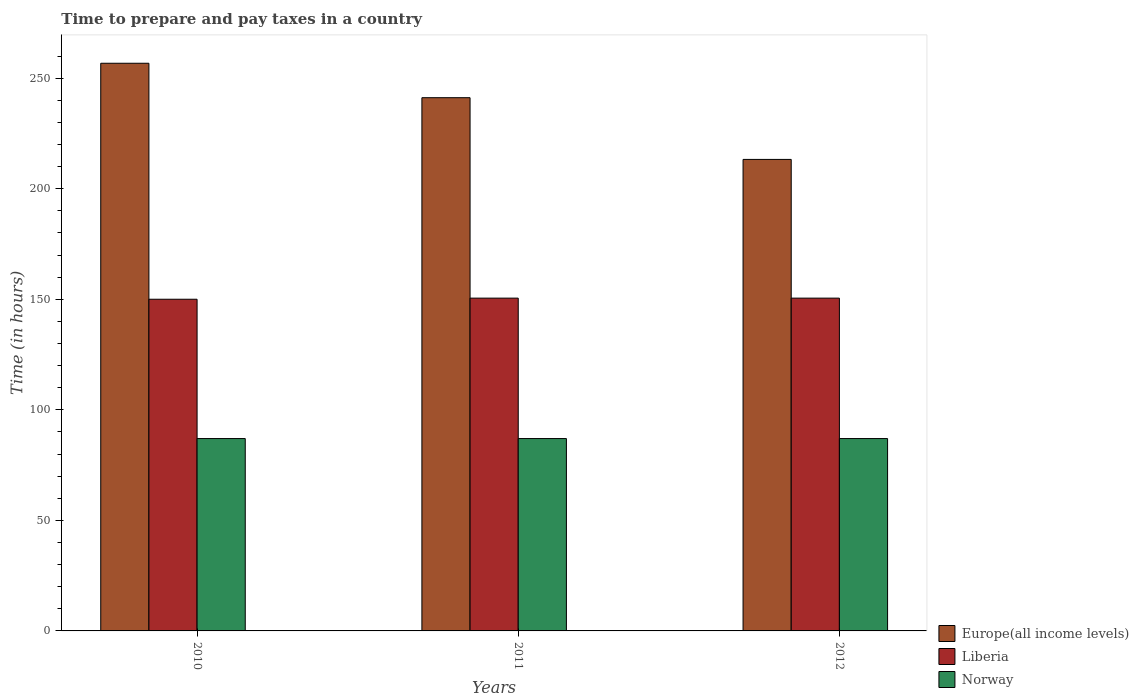How many different coloured bars are there?
Offer a terse response. 3. How many bars are there on the 3rd tick from the left?
Ensure brevity in your answer.  3. How many bars are there on the 2nd tick from the right?
Provide a succinct answer. 3. What is the number of hours required to prepare and pay taxes in Europe(all income levels) in 2012?
Offer a terse response. 213.24. Across all years, what is the maximum number of hours required to prepare and pay taxes in Norway?
Make the answer very short. 87. Across all years, what is the minimum number of hours required to prepare and pay taxes in Europe(all income levels)?
Your answer should be compact. 213.24. In which year was the number of hours required to prepare and pay taxes in Liberia minimum?
Your response must be concise. 2010. What is the total number of hours required to prepare and pay taxes in Norway in the graph?
Keep it short and to the point. 261. What is the difference between the number of hours required to prepare and pay taxes in Liberia in 2010 and that in 2012?
Your answer should be compact. -0.5. What is the difference between the number of hours required to prepare and pay taxes in Liberia in 2010 and the number of hours required to prepare and pay taxes in Norway in 2012?
Your answer should be very brief. 63. What is the average number of hours required to prepare and pay taxes in Europe(all income levels) per year?
Provide a succinct answer. 237.04. In the year 2011, what is the difference between the number of hours required to prepare and pay taxes in Norway and number of hours required to prepare and pay taxes in Liberia?
Provide a short and direct response. -63.5. What is the difference between the highest and the lowest number of hours required to prepare and pay taxes in Liberia?
Give a very brief answer. 0.5. In how many years, is the number of hours required to prepare and pay taxes in Liberia greater than the average number of hours required to prepare and pay taxes in Liberia taken over all years?
Ensure brevity in your answer.  2. What does the 2nd bar from the left in 2012 represents?
Keep it short and to the point. Liberia. What does the 2nd bar from the right in 2010 represents?
Your answer should be very brief. Liberia. Is it the case that in every year, the sum of the number of hours required to prepare and pay taxes in Norway and number of hours required to prepare and pay taxes in Liberia is greater than the number of hours required to prepare and pay taxes in Europe(all income levels)?
Your response must be concise. No. How many bars are there?
Provide a short and direct response. 9. What is the difference between two consecutive major ticks on the Y-axis?
Make the answer very short. 50. Are the values on the major ticks of Y-axis written in scientific E-notation?
Your answer should be very brief. No. Does the graph contain grids?
Your answer should be compact. No. How many legend labels are there?
Your response must be concise. 3. What is the title of the graph?
Provide a succinct answer. Time to prepare and pay taxes in a country. What is the label or title of the X-axis?
Provide a succinct answer. Years. What is the label or title of the Y-axis?
Offer a very short reply. Time (in hours). What is the Time (in hours) in Europe(all income levels) in 2010?
Ensure brevity in your answer.  256.72. What is the Time (in hours) in Liberia in 2010?
Ensure brevity in your answer.  150. What is the Time (in hours) of Europe(all income levels) in 2011?
Keep it short and to the point. 241.15. What is the Time (in hours) in Liberia in 2011?
Your answer should be very brief. 150.5. What is the Time (in hours) in Europe(all income levels) in 2012?
Make the answer very short. 213.24. What is the Time (in hours) of Liberia in 2012?
Give a very brief answer. 150.5. What is the Time (in hours) of Norway in 2012?
Offer a very short reply. 87. Across all years, what is the maximum Time (in hours) in Europe(all income levels)?
Keep it short and to the point. 256.72. Across all years, what is the maximum Time (in hours) in Liberia?
Ensure brevity in your answer.  150.5. Across all years, what is the minimum Time (in hours) of Europe(all income levels)?
Provide a succinct answer. 213.24. Across all years, what is the minimum Time (in hours) of Liberia?
Keep it short and to the point. 150. Across all years, what is the minimum Time (in hours) in Norway?
Give a very brief answer. 87. What is the total Time (in hours) in Europe(all income levels) in the graph?
Provide a short and direct response. 711.11. What is the total Time (in hours) of Liberia in the graph?
Your answer should be very brief. 451. What is the total Time (in hours) of Norway in the graph?
Your response must be concise. 261. What is the difference between the Time (in hours) of Europe(all income levels) in 2010 and that in 2011?
Your answer should be very brief. 15.57. What is the difference between the Time (in hours) of Norway in 2010 and that in 2011?
Give a very brief answer. 0. What is the difference between the Time (in hours) in Europe(all income levels) in 2010 and that in 2012?
Keep it short and to the point. 43.48. What is the difference between the Time (in hours) in Norway in 2010 and that in 2012?
Offer a terse response. 0. What is the difference between the Time (in hours) of Europe(all income levels) in 2011 and that in 2012?
Offer a very short reply. 27.91. What is the difference between the Time (in hours) in Norway in 2011 and that in 2012?
Give a very brief answer. 0. What is the difference between the Time (in hours) of Europe(all income levels) in 2010 and the Time (in hours) of Liberia in 2011?
Provide a short and direct response. 106.22. What is the difference between the Time (in hours) of Europe(all income levels) in 2010 and the Time (in hours) of Norway in 2011?
Offer a terse response. 169.72. What is the difference between the Time (in hours) in Liberia in 2010 and the Time (in hours) in Norway in 2011?
Keep it short and to the point. 63. What is the difference between the Time (in hours) of Europe(all income levels) in 2010 and the Time (in hours) of Liberia in 2012?
Provide a succinct answer. 106.22. What is the difference between the Time (in hours) in Europe(all income levels) in 2010 and the Time (in hours) in Norway in 2012?
Your answer should be very brief. 169.72. What is the difference between the Time (in hours) of Europe(all income levels) in 2011 and the Time (in hours) of Liberia in 2012?
Give a very brief answer. 90.65. What is the difference between the Time (in hours) in Europe(all income levels) in 2011 and the Time (in hours) in Norway in 2012?
Your answer should be very brief. 154.15. What is the difference between the Time (in hours) of Liberia in 2011 and the Time (in hours) of Norway in 2012?
Your response must be concise. 63.5. What is the average Time (in hours) of Europe(all income levels) per year?
Give a very brief answer. 237.04. What is the average Time (in hours) of Liberia per year?
Your response must be concise. 150.33. In the year 2010, what is the difference between the Time (in hours) of Europe(all income levels) and Time (in hours) of Liberia?
Offer a terse response. 106.72. In the year 2010, what is the difference between the Time (in hours) in Europe(all income levels) and Time (in hours) in Norway?
Your answer should be very brief. 169.72. In the year 2010, what is the difference between the Time (in hours) in Liberia and Time (in hours) in Norway?
Ensure brevity in your answer.  63. In the year 2011, what is the difference between the Time (in hours) of Europe(all income levels) and Time (in hours) of Liberia?
Keep it short and to the point. 90.65. In the year 2011, what is the difference between the Time (in hours) in Europe(all income levels) and Time (in hours) in Norway?
Offer a terse response. 154.15. In the year 2011, what is the difference between the Time (in hours) in Liberia and Time (in hours) in Norway?
Keep it short and to the point. 63.5. In the year 2012, what is the difference between the Time (in hours) in Europe(all income levels) and Time (in hours) in Liberia?
Offer a very short reply. 62.74. In the year 2012, what is the difference between the Time (in hours) of Europe(all income levels) and Time (in hours) of Norway?
Keep it short and to the point. 126.24. In the year 2012, what is the difference between the Time (in hours) in Liberia and Time (in hours) in Norway?
Ensure brevity in your answer.  63.5. What is the ratio of the Time (in hours) of Europe(all income levels) in 2010 to that in 2011?
Your answer should be very brief. 1.06. What is the ratio of the Time (in hours) in Europe(all income levels) in 2010 to that in 2012?
Offer a very short reply. 1.2. What is the ratio of the Time (in hours) in Liberia in 2010 to that in 2012?
Your response must be concise. 1. What is the ratio of the Time (in hours) of Norway in 2010 to that in 2012?
Ensure brevity in your answer.  1. What is the ratio of the Time (in hours) of Europe(all income levels) in 2011 to that in 2012?
Your response must be concise. 1.13. What is the ratio of the Time (in hours) in Liberia in 2011 to that in 2012?
Your response must be concise. 1. What is the ratio of the Time (in hours) of Norway in 2011 to that in 2012?
Keep it short and to the point. 1. What is the difference between the highest and the second highest Time (in hours) of Europe(all income levels)?
Your answer should be compact. 15.57. What is the difference between the highest and the second highest Time (in hours) in Liberia?
Give a very brief answer. 0. What is the difference between the highest and the second highest Time (in hours) of Norway?
Your answer should be very brief. 0. What is the difference between the highest and the lowest Time (in hours) of Europe(all income levels)?
Keep it short and to the point. 43.48. What is the difference between the highest and the lowest Time (in hours) in Liberia?
Offer a terse response. 0.5. 